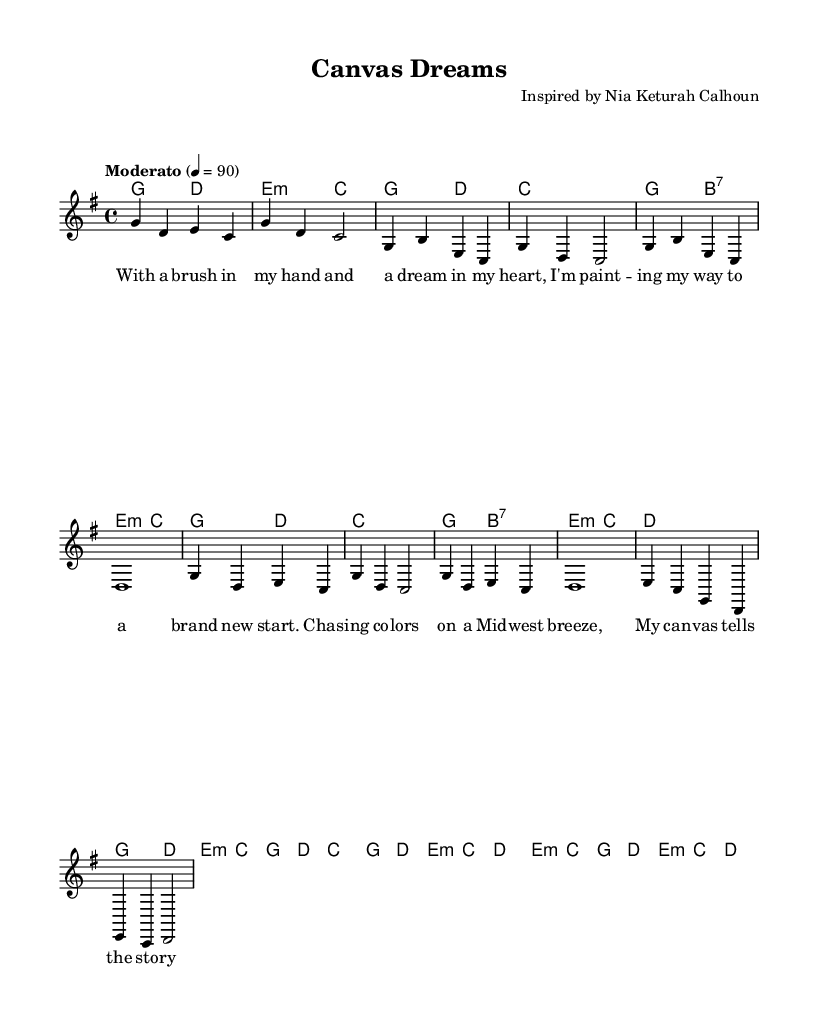What is the key signature of this music? The key signature is G major, which has one sharp (F#). This can be determined by looking at the key signature indicated at the beginning of the score, which is notated as 'g' in the LilyPond code.
Answer: G major What is the time signature of this music? The time signature is 4/4, which means there are four beats per measure and the quarter note gets one beat. This can be found in the score where it indicates '4/4' in the global settings of the LilyPond code.
Answer: 4/4 What is the tempo marking for this piece? The tempo marking mentioned in the score is "Moderato," and it indicates a moderate speed, which corresponds to a metronome marking of 90 beats per minute. This is directly indicated in the tempo configuration within the global settings of the code.
Answer: Moderato How many measures are in the chorus? The chorus consists of two measures, as represented in the LilyPond code where the 'chorus' section is clearly defined and contains two distinct lines indicated as one overall musical section.
Answer: 2 What instrument is this score meant for? This score is meant for piano, as indicated by the use of a staff and chord names specifically for a harmonic accompaniment typical for contemporary country music. The lack of specific instrument notations beyond the standard configurations further confirms its purpose.
Answer: Piano What thematic element is depicted in the lyrics? The lyrics speak about artistic dreams and creating art, which parallels the artist's journey and aspirations. This thematic element is highlighted through the imagery of painting and personal storytelling within the lyrics.
Answer: Artistic dreams What style of music does this piece represent? The piece represents contemporary country ballads, which can be inferred from the melodic structure, lyrical themes reflecting personal stories, and the use of simple, emotive harmonic progressions often found in this genre.
Answer: Contemporary country 